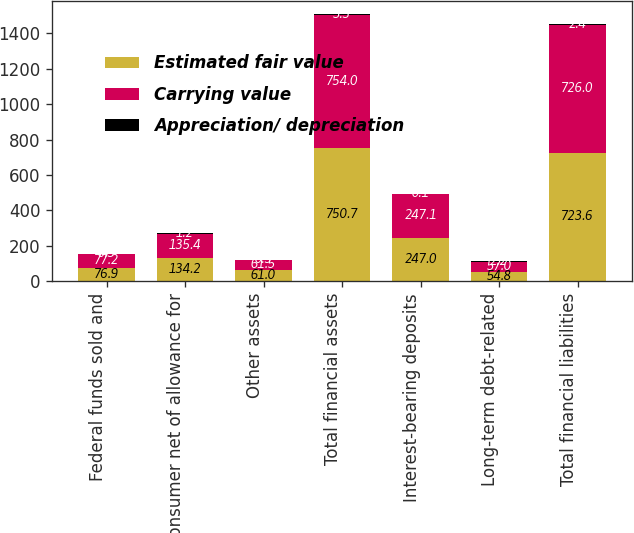<chart> <loc_0><loc_0><loc_500><loc_500><stacked_bar_chart><ecel><fcel>Federal funds sold and<fcel>Consumer net of allowance for<fcel>Other assets<fcel>Total financial assets<fcel>Interest-bearing deposits<fcel>Long-term debt-related<fcel>Total financial liabilities<nl><fcel>Estimated fair value<fcel>76.9<fcel>134.2<fcel>61<fcel>750.7<fcel>247<fcel>54.8<fcel>723.6<nl><fcel>Carrying value<fcel>77.2<fcel>135.4<fcel>61.5<fcel>754<fcel>247.1<fcel>57<fcel>726<nl><fcel>Appreciation/ depreciation<fcel>0.3<fcel>1.2<fcel>0.5<fcel>3.3<fcel>0.1<fcel>2.2<fcel>2.4<nl></chart> 